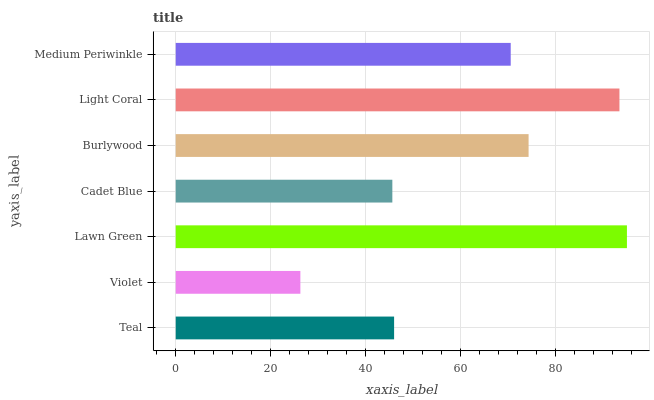Is Violet the minimum?
Answer yes or no. Yes. Is Lawn Green the maximum?
Answer yes or no. Yes. Is Lawn Green the minimum?
Answer yes or no. No. Is Violet the maximum?
Answer yes or no. No. Is Lawn Green greater than Violet?
Answer yes or no. Yes. Is Violet less than Lawn Green?
Answer yes or no. Yes. Is Violet greater than Lawn Green?
Answer yes or no. No. Is Lawn Green less than Violet?
Answer yes or no. No. Is Medium Periwinkle the high median?
Answer yes or no. Yes. Is Medium Periwinkle the low median?
Answer yes or no. Yes. Is Cadet Blue the high median?
Answer yes or no. No. Is Lawn Green the low median?
Answer yes or no. No. 